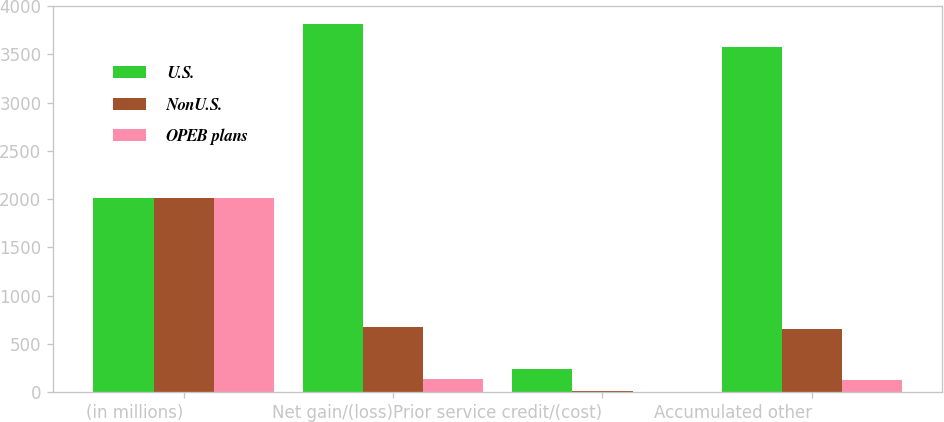<chart> <loc_0><loc_0><loc_500><loc_500><stacked_bar_chart><ecel><fcel>(in millions)<fcel>Net gain/(loss)<fcel>Prior service credit/(cost)<fcel>Accumulated other<nl><fcel>U.S.<fcel>2012<fcel>3814<fcel>237<fcel>3577<nl><fcel>NonU.S.<fcel>2012<fcel>676<fcel>18<fcel>658<nl><fcel>OPEB plans<fcel>2012<fcel>133<fcel>1<fcel>132<nl></chart> 